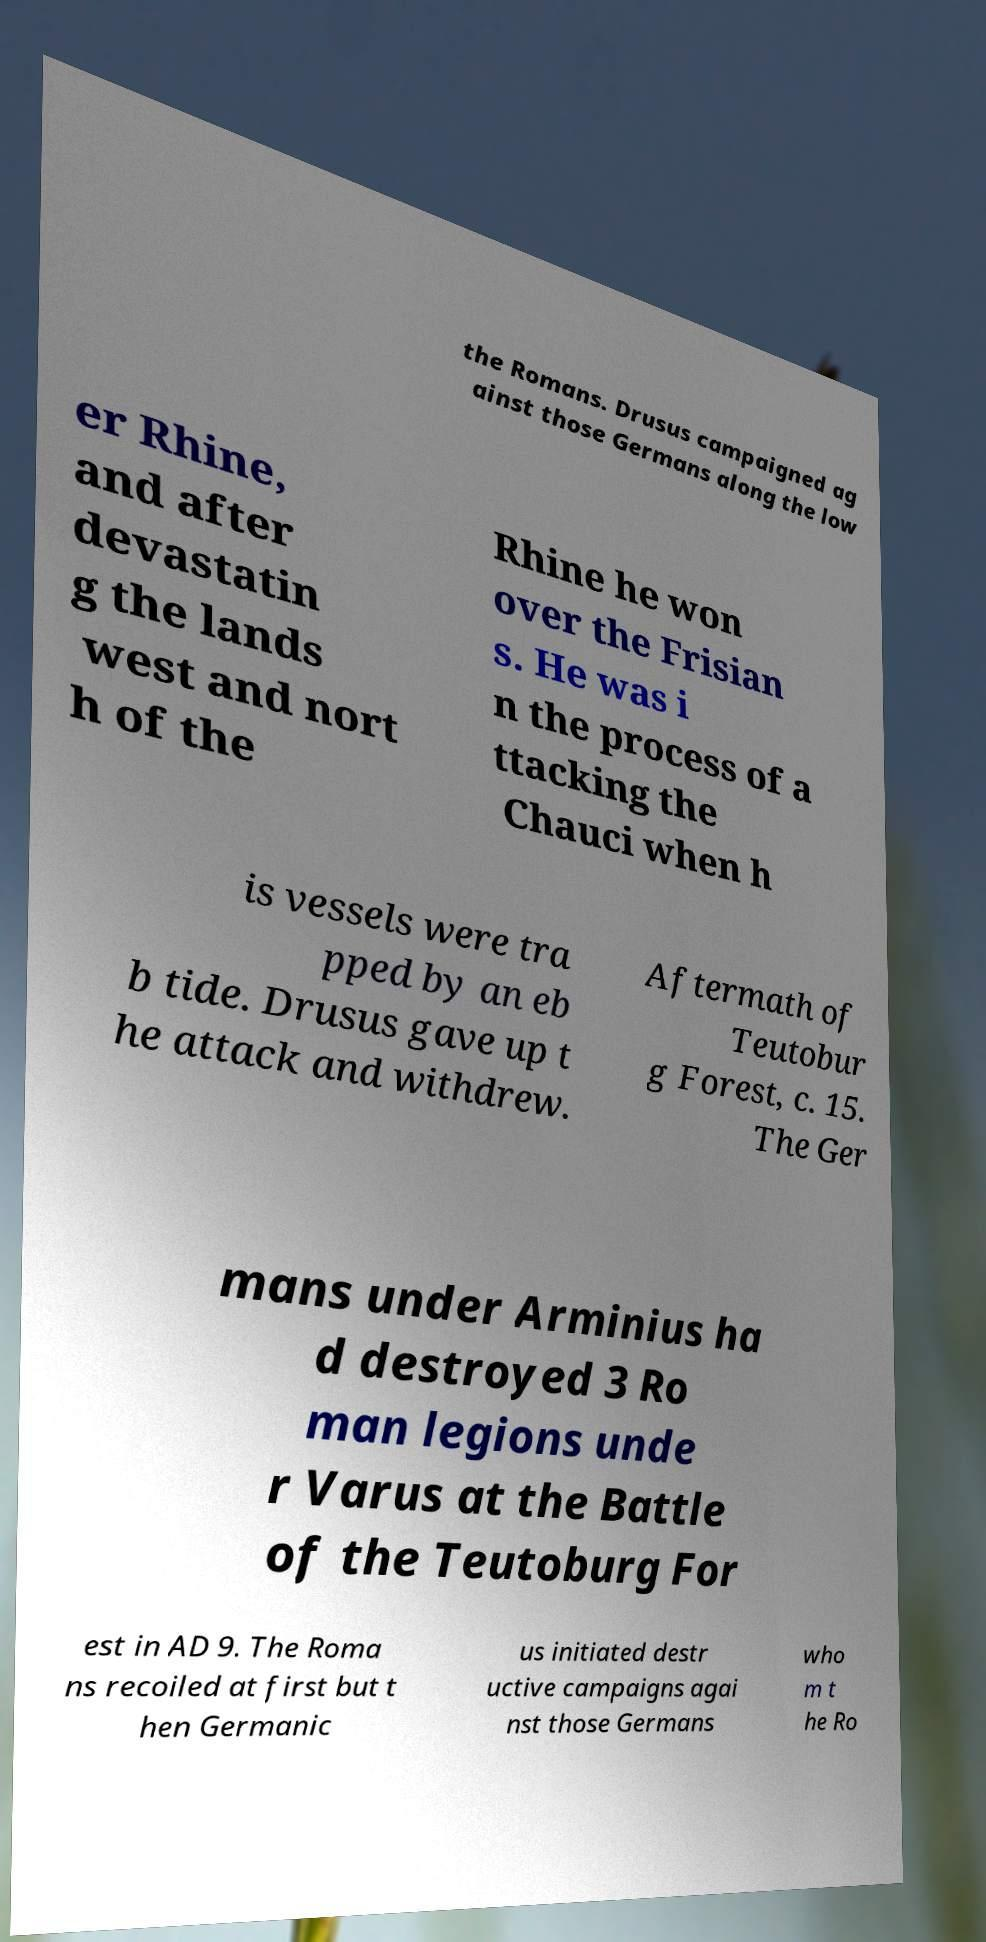Could you extract and type out the text from this image? the Romans. Drusus campaigned ag ainst those Germans along the low er Rhine, and after devastatin g the lands west and nort h of the Rhine he won over the Frisian s. He was i n the process of a ttacking the Chauci when h is vessels were tra pped by an eb b tide. Drusus gave up t he attack and withdrew. Aftermath of Teutobur g Forest, c. 15. The Ger mans under Arminius ha d destroyed 3 Ro man legions unde r Varus at the Battle of the Teutoburg For est in AD 9. The Roma ns recoiled at first but t hen Germanic us initiated destr uctive campaigns agai nst those Germans who m t he Ro 